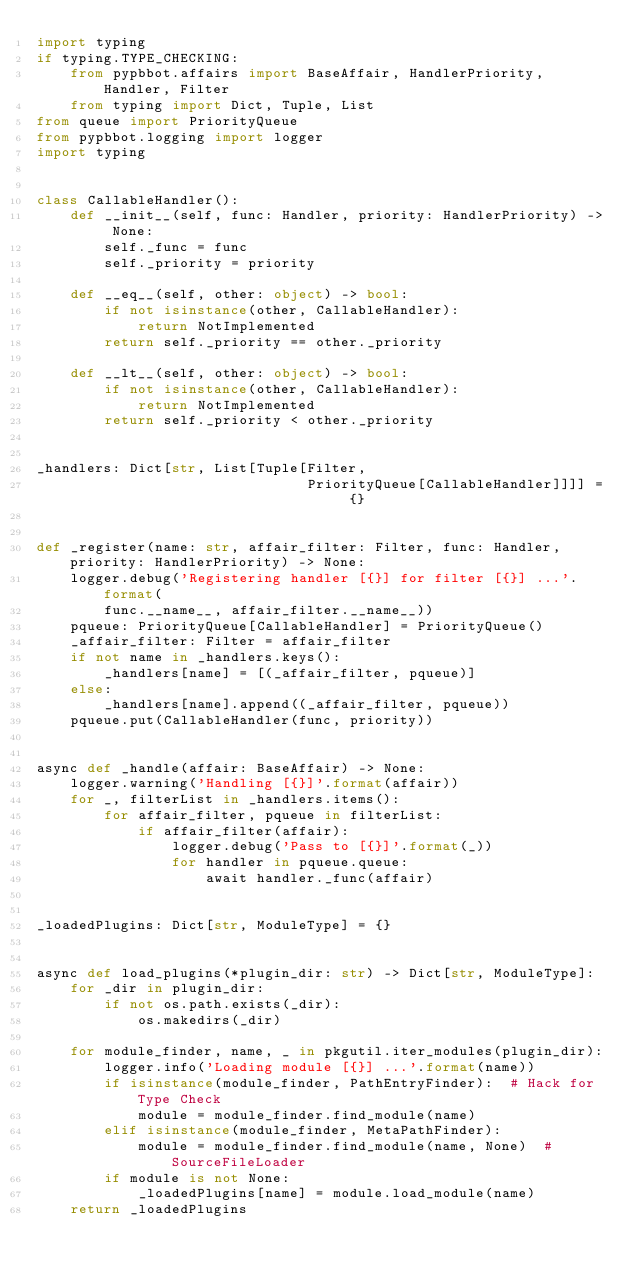Convert code to text. <code><loc_0><loc_0><loc_500><loc_500><_Python_>import typing
if typing.TYPE_CHECKING:
    from pypbbot.affairs import BaseAffair, HandlerPriority, Handler, Filter
    from typing import Dict, Tuple, List
from queue import PriorityQueue
from pypbbot.logging import logger
import typing


class CallableHandler():
    def __init__(self, func: Handler, priority: HandlerPriority) -> None:
        self._func = func
        self._priority = priority

    def __eq__(self, other: object) -> bool:
        if not isinstance(other, CallableHandler):
            return NotImplemented
        return self._priority == other._priority

    def __lt__(self, other: object) -> bool:
        if not isinstance(other, CallableHandler):
            return NotImplemented
        return self._priority < other._priority


_handlers: Dict[str, List[Tuple[Filter,
                                PriorityQueue[CallableHandler]]]] = {}


def _register(name: str, affair_filter: Filter, func: Handler, priority: HandlerPriority) -> None:
    logger.debug('Registering handler [{}] for filter [{}] ...'.format(
        func.__name__, affair_filter.__name__))
    pqueue: PriorityQueue[CallableHandler] = PriorityQueue()
    _affair_filter: Filter = affair_filter
    if not name in _handlers.keys():
        _handlers[name] = [(_affair_filter, pqueue)]
    else:
        _handlers[name].append((_affair_filter, pqueue))
    pqueue.put(CallableHandler(func, priority))


async def _handle(affair: BaseAffair) -> None:
    logger.warning('Handling [{}]'.format(affair))
    for _, filterList in _handlers.items():
        for affair_filter, pqueue in filterList:
            if affair_filter(affair):
                logger.debug('Pass to [{}]'.format(_))
                for handler in pqueue.queue:
                    await handler._func(affair)


_loadedPlugins: Dict[str, ModuleType] = {}


async def load_plugins(*plugin_dir: str) -> Dict[str, ModuleType]:
    for _dir in plugin_dir:
        if not os.path.exists(_dir):
            os.makedirs(_dir)

    for module_finder, name, _ in pkgutil.iter_modules(plugin_dir):
        logger.info('Loading module [{}] ...'.format(name))
        if isinstance(module_finder, PathEntryFinder):  # Hack for Type Check
            module = module_finder.find_module(name)
        elif isinstance(module_finder, MetaPathFinder):
            module = module_finder.find_module(name, None)  # SourceFileLoader
        if module is not None:
            _loadedPlugins[name] = module.load_module(name)
    return _loadedPlugins
</code> 